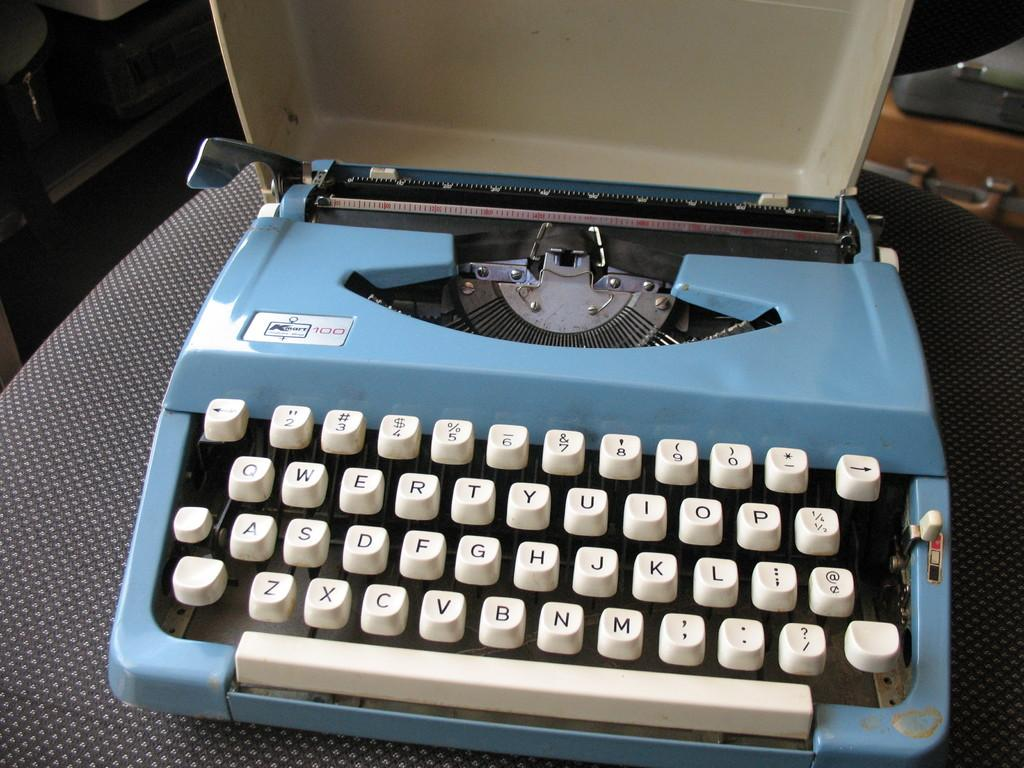<image>
Summarize the visual content of the image. An old blue KMart typewriter with the cover removed. 